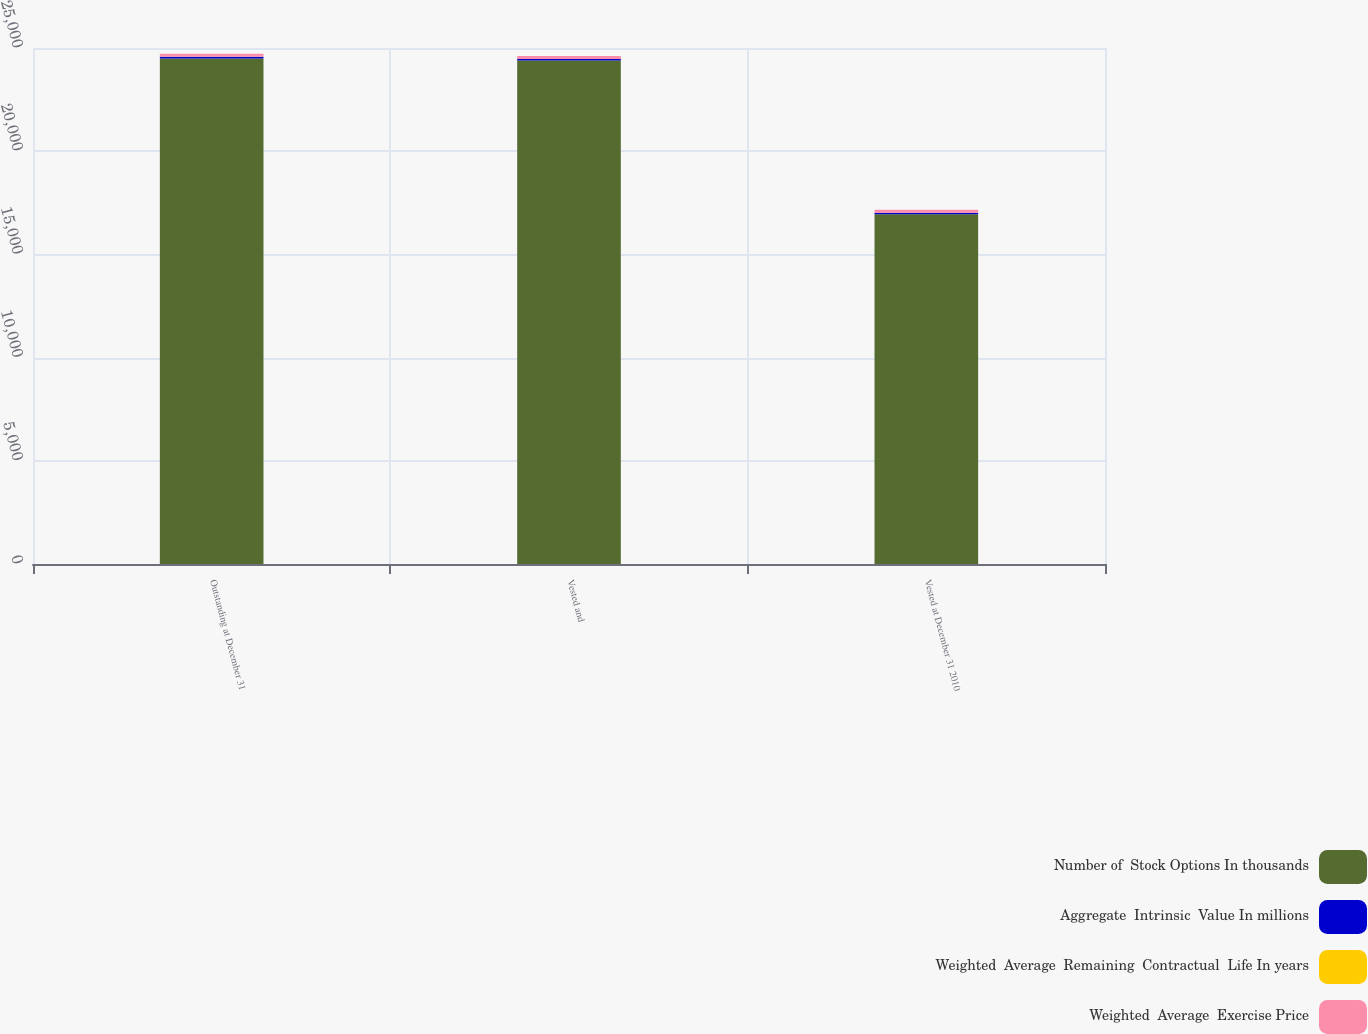Convert chart to OTSL. <chart><loc_0><loc_0><loc_500><loc_500><stacked_bar_chart><ecel><fcel>Outstanding at December 31<fcel>Vested and<fcel>Vested at December 31 2010<nl><fcel>Number of  Stock Options In thousands<fcel>24497<fcel>24391<fcel>16943<nl><fcel>Aggregate  Intrinsic  Value In millions<fcel>75.9<fcel>75.89<fcel>72.88<nl><fcel>Weighted  Average  Remaining  Contractual  Life In years<fcel>5.9<fcel>5.9<fcel>4.8<nl><fcel>Weighted  Average  Exercise Price<fcel>137<fcel>137<fcel>137<nl></chart> 